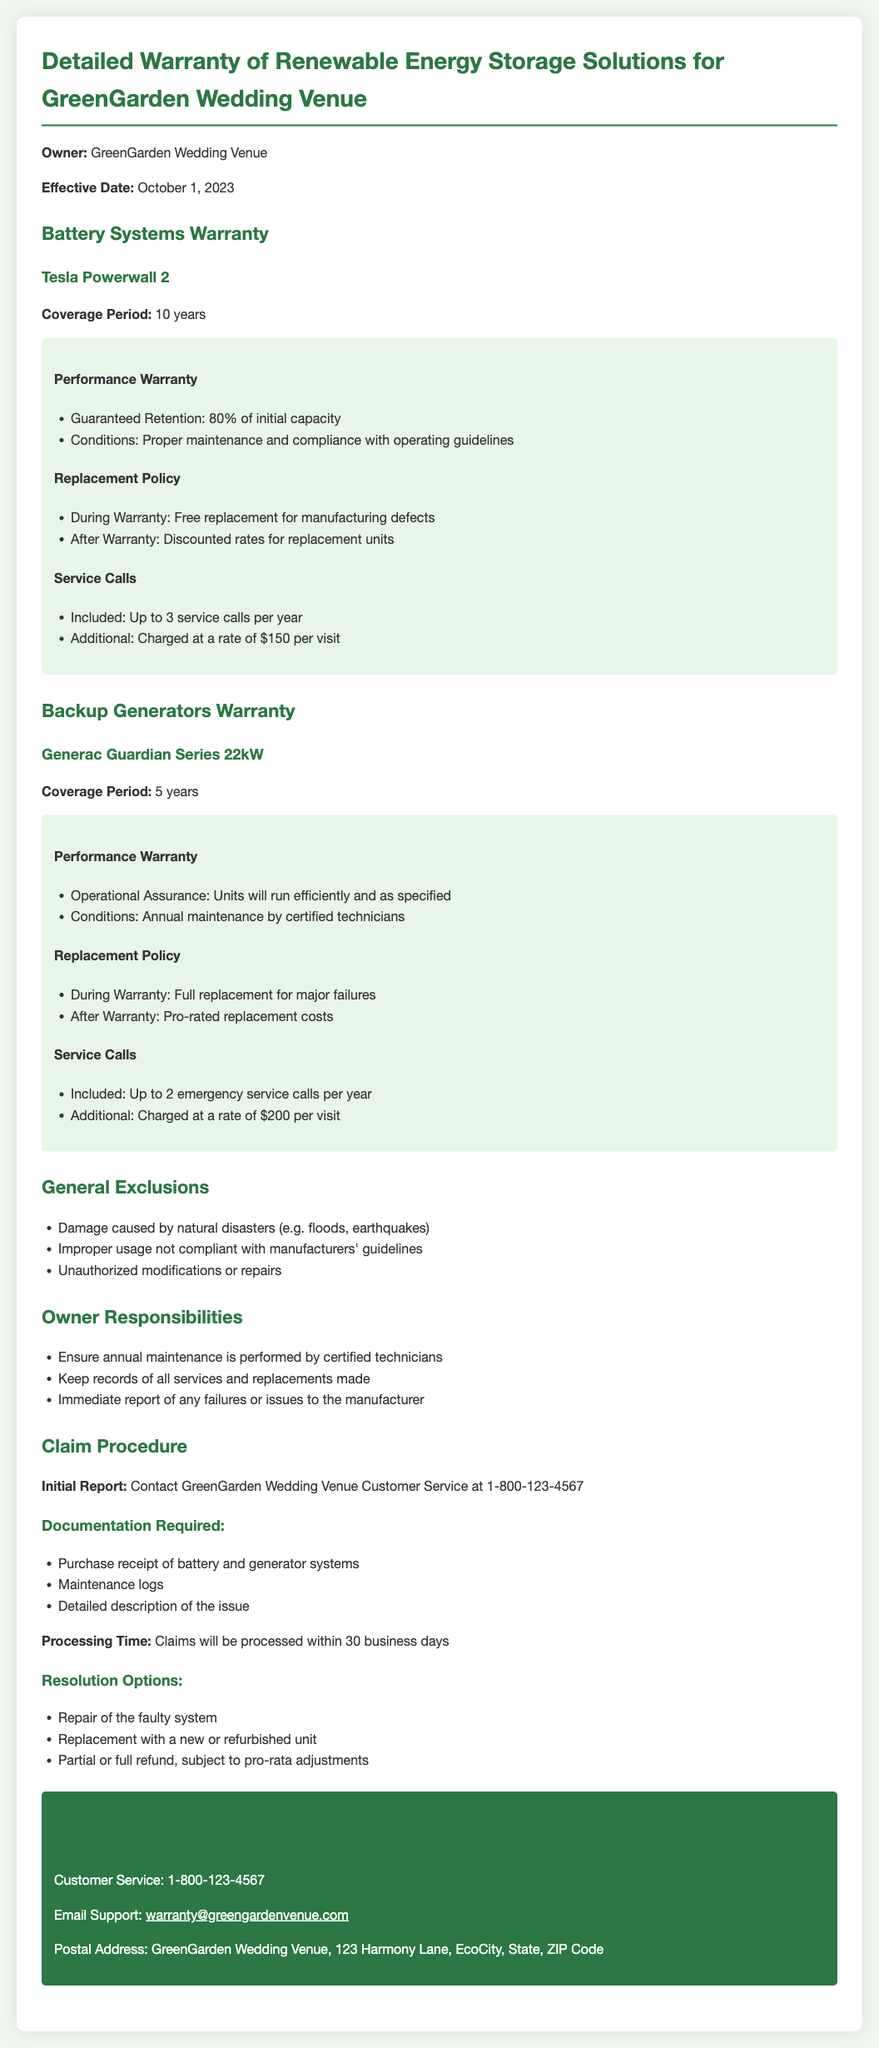What is the coverage period for the Tesla Powerwall 2? The coverage period for the Tesla Powerwall 2 is specified in the warranty section, which mentions a duration of 10 years.
Answer: 10 years What is the replacement policy during the warranty for the Generac Guardian Series 22kW? The warranty outlines that during the warranty period, full replacement is provided for major failures of the Generac Guardian Series 22kW.
Answer: Full replacement for major failures What is the annual service call limit for the Tesla Powerwall 2? The document states that the Tesla Powerwall 2 includes up to 3 service calls per year as part of its warranty.
Answer: Up to 3 service calls What happens if I don't perform maintenance on the backup generator? The warranty indicates that failure to perform annual maintenance by certified technicians could affect operational assurance and performance.
Answer: Affects operational assurance How long will claims take to process? The document mentions that claims will be processed within a specific time frame outlined in the claim procedure section.
Answer: 30 business days What is the contact number for customer service? The contact information section specifies the customer service number as listed in the warranty document.
Answer: 1-800-123-4567 What are the conditions for the battery systems performance warranty? The battery systems warranty specifies conditions such as proper maintenance and compliance with operating guidelines for the performance warranty.
Answer: Proper maintenance and compliance What must be included in the documentation for a warranty claim? The claim procedure section lists required documentation, including the purchase receipt, maintenance logs, and a detailed description of the issue.
Answer: Purchase receipt, maintenance logs, detailed description of the issue What is the email support address? The contact information section provides the specific email address for warranty support.
Answer: warranty@greengardenvenue.com 